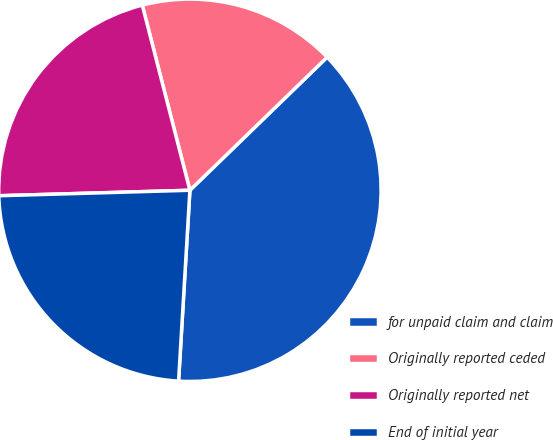Convert chart to OTSL. <chart><loc_0><loc_0><loc_500><loc_500><pie_chart><fcel>for unpaid claim and claim<fcel>Originally reported ceded<fcel>Originally reported net<fcel>End of initial year<nl><fcel>38.2%<fcel>16.75%<fcel>21.45%<fcel>23.6%<nl></chart> 